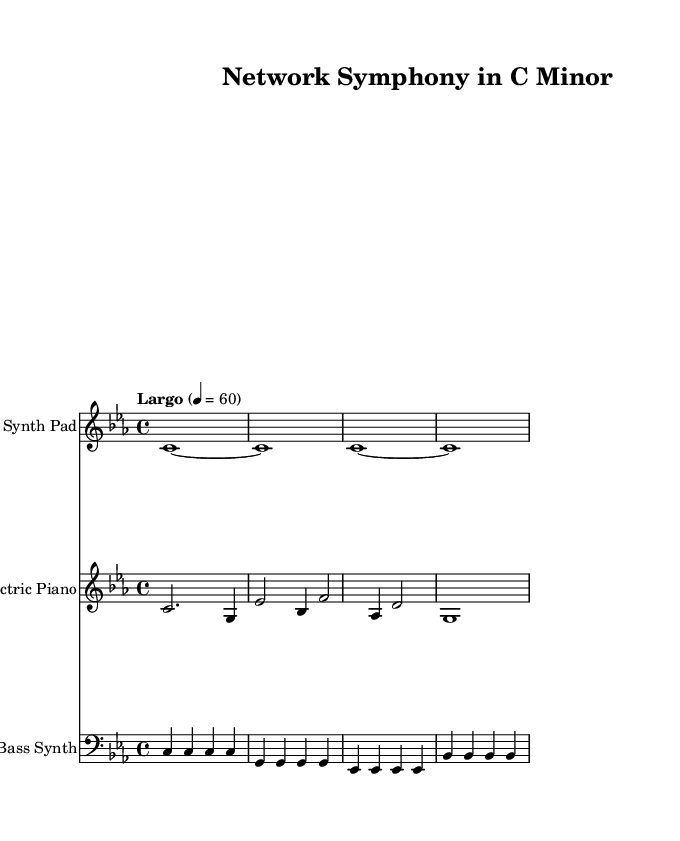What is the key signature of this music? The key signature indicates the tonality of a piece. Here, it is C minor, as denoted by the two flats (B flat and E flat) shown at the beginning of the staff.
Answer: C minor What is the time signature of this composition? The time signature is found at the beginning of the score. Here, it is 4/4, meaning there are four beats in a measure and a quarter note gets one beat.
Answer: 4/4 What is the tempo marking of this piece? The tempo marking is indicated in the score above the first measure as "Largo" with a metronome marking of 60. This means the piece should be played slowly at a speed of 60 beats per minute.
Answer: Largo How many instruments are present in the score? The score shows a total of three different instruments: Synth Pad, Electric Piano, and Bass Synth. Each has its unique staff in the score, indicating a varied texture.
Answer: Three Which clef is used for the Electric Piano? The Electric Piano is notated using the treble clef, as indicated by the clef sign placed at the beginning of its staff. This clef is typically used for higher pitches.
Answer: Treble For how many measures does the Synth Pad hold the note C? The Synth Pad holds the note C for four measures, showing a sustained sound through whole notes (indicated with “c1~” followed by “c1” repeated).
Answer: Four measures What type of music genre does this piece belong to? The characteristics of this piece, including its ambient soundscapes and the use of synthesizers, categorizes it as Experimental music, which often aims to explore new sound textures and compositions.
Answer: Experimental 